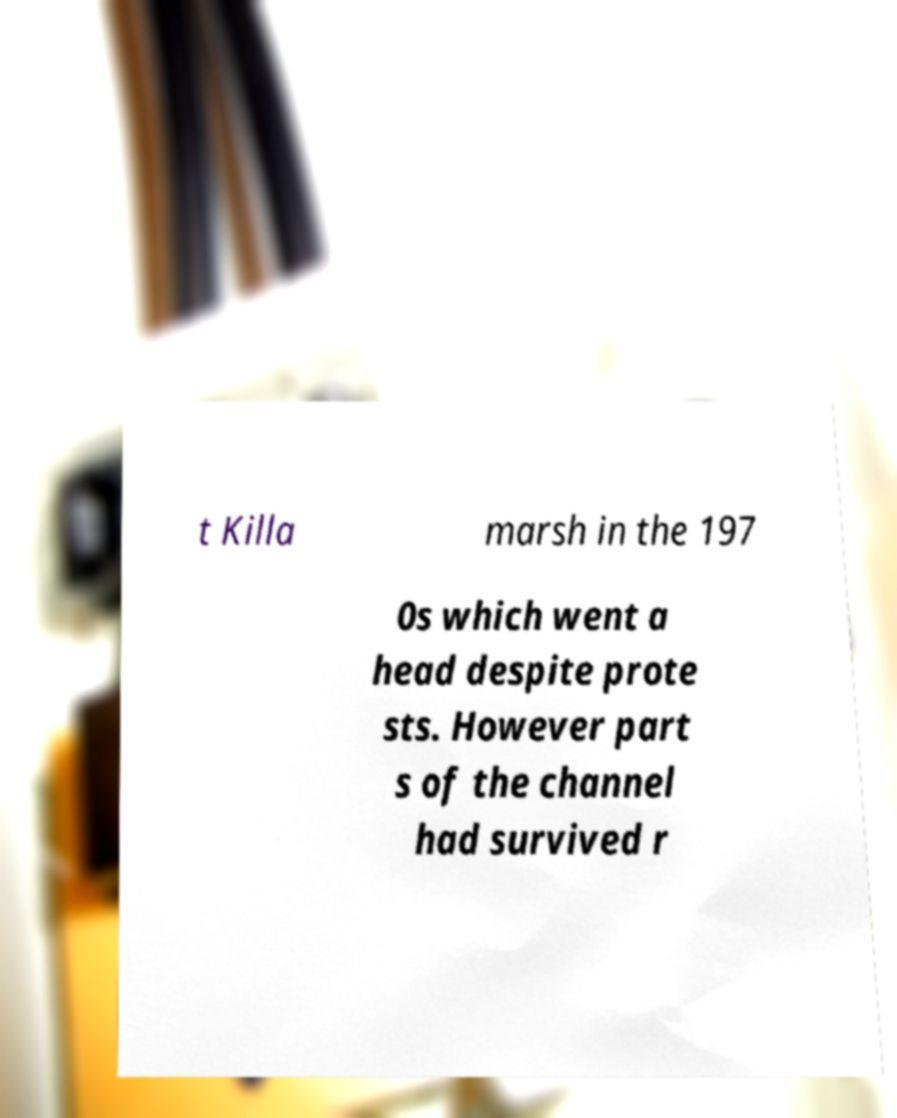Could you extract and type out the text from this image? t Killa marsh in the 197 0s which went a head despite prote sts. However part s of the channel had survived r 